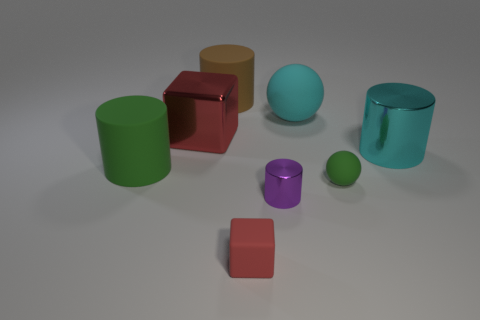Are there any objects in the image that have a texture or pattern? None of the objects in the image feature a visible texture or pattern. All objects have solid, matte, or glossy finishes without additional detailing. 